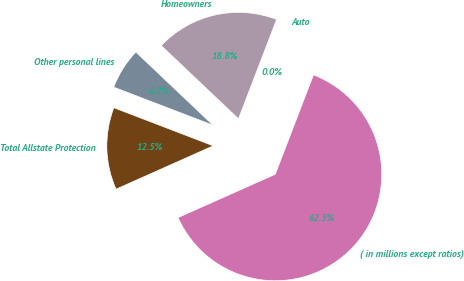Convert chart. <chart><loc_0><loc_0><loc_500><loc_500><pie_chart><fcel>( in millions except ratios)<fcel>Auto<fcel>Homeowners<fcel>Other personal lines<fcel>Total Allstate Protection<nl><fcel>62.49%<fcel>0.01%<fcel>18.75%<fcel>6.25%<fcel>12.5%<nl></chart> 